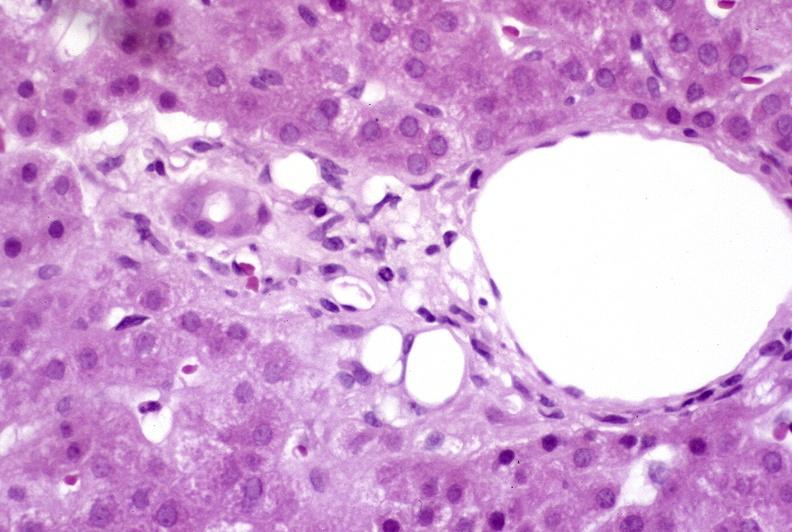does this image show recovery of ducts?
Answer the question using a single word or phrase. Yes 